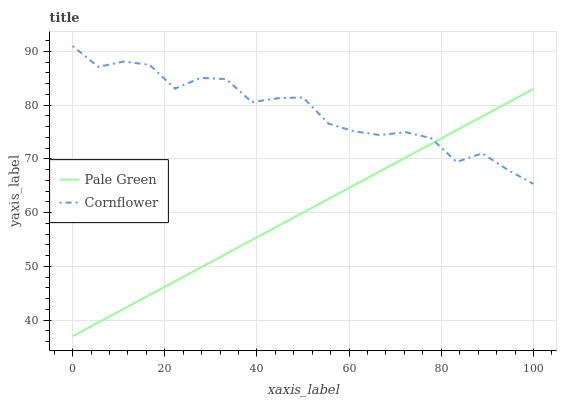Does Pale Green have the minimum area under the curve?
Answer yes or no. Yes. Does Cornflower have the maximum area under the curve?
Answer yes or no. Yes. Does Pale Green have the maximum area under the curve?
Answer yes or no. No. Is Pale Green the smoothest?
Answer yes or no. Yes. Is Cornflower the roughest?
Answer yes or no. Yes. Is Pale Green the roughest?
Answer yes or no. No. Does Pale Green have the lowest value?
Answer yes or no. Yes. Does Cornflower have the highest value?
Answer yes or no. Yes. Does Pale Green have the highest value?
Answer yes or no. No. Does Pale Green intersect Cornflower?
Answer yes or no. Yes. Is Pale Green less than Cornflower?
Answer yes or no. No. Is Pale Green greater than Cornflower?
Answer yes or no. No. 